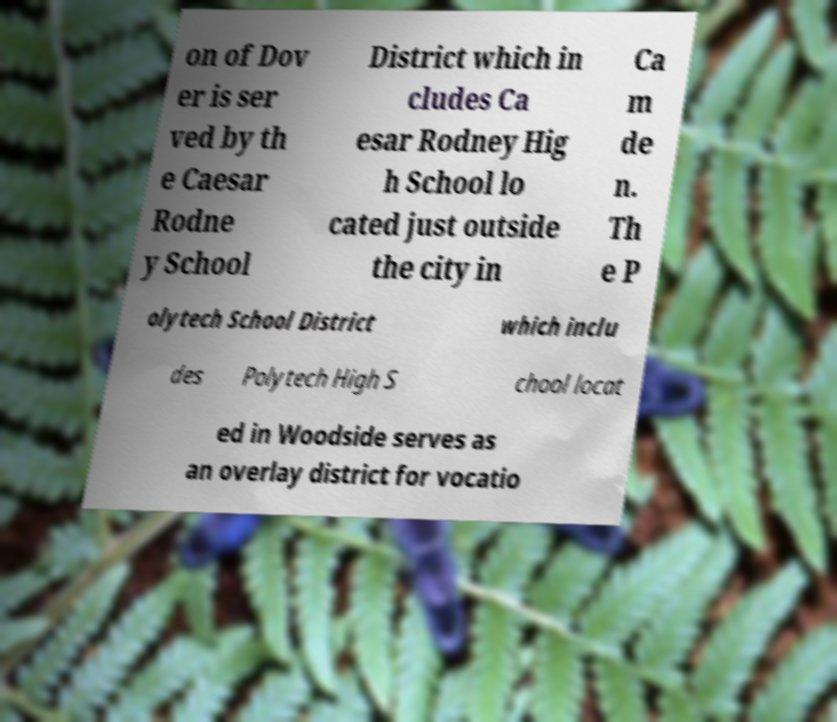Can you read and provide the text displayed in the image?This photo seems to have some interesting text. Can you extract and type it out for me? on of Dov er is ser ved by th e Caesar Rodne y School District which in cludes Ca esar Rodney Hig h School lo cated just outside the city in Ca m de n. Th e P olytech School District which inclu des Polytech High S chool locat ed in Woodside serves as an overlay district for vocatio 